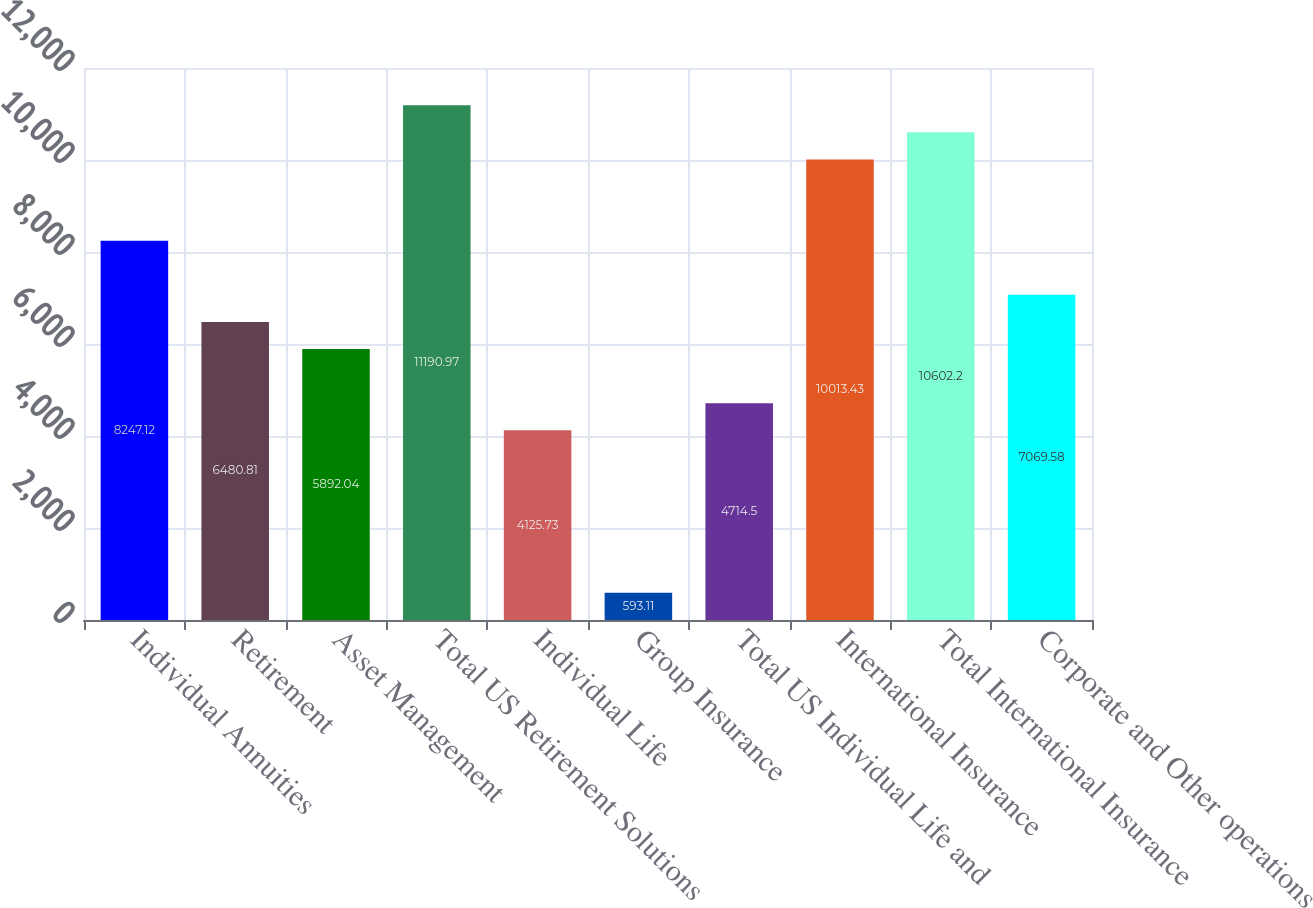<chart> <loc_0><loc_0><loc_500><loc_500><bar_chart><fcel>Individual Annuities<fcel>Retirement<fcel>Asset Management<fcel>Total US Retirement Solutions<fcel>Individual Life<fcel>Group Insurance<fcel>Total US Individual Life and<fcel>International Insurance<fcel>Total International Insurance<fcel>Corporate and Other operations<nl><fcel>8247.12<fcel>6480.81<fcel>5892.04<fcel>11191<fcel>4125.73<fcel>593.11<fcel>4714.5<fcel>10013.4<fcel>10602.2<fcel>7069.58<nl></chart> 